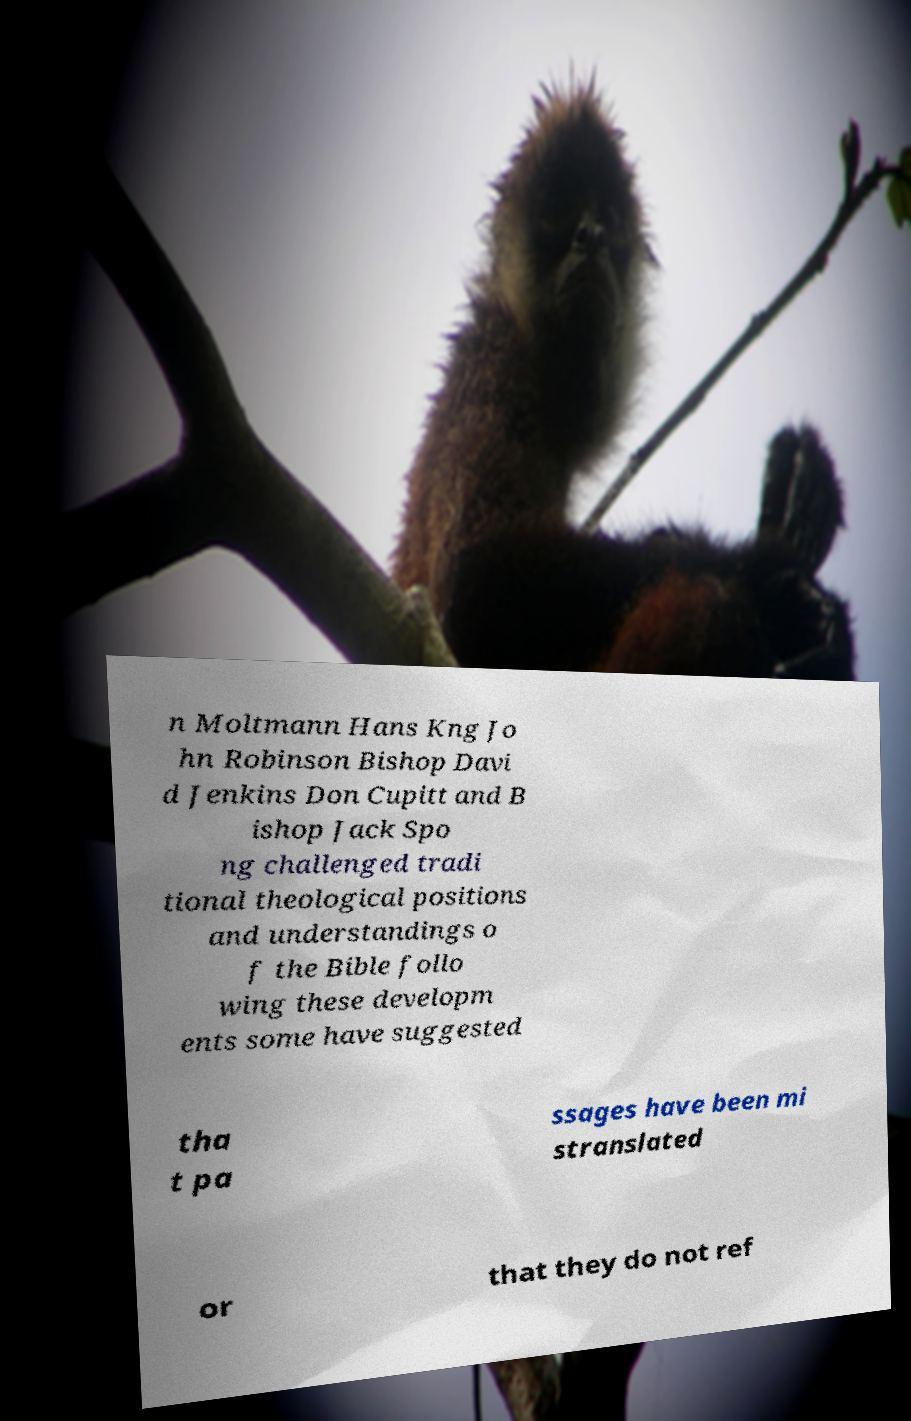Could you extract and type out the text from this image? n Moltmann Hans Kng Jo hn Robinson Bishop Davi d Jenkins Don Cupitt and B ishop Jack Spo ng challenged tradi tional theological positions and understandings o f the Bible follo wing these developm ents some have suggested tha t pa ssages have been mi stranslated or that they do not ref 